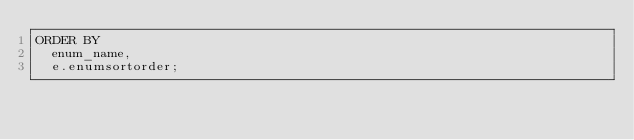<code> <loc_0><loc_0><loc_500><loc_500><_SQL_>ORDER BY
  enum_name,
  e.enumsortorder;
</code> 